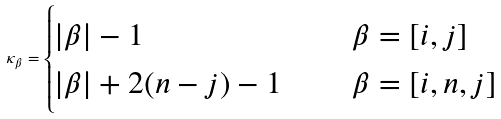Convert formula to latex. <formula><loc_0><loc_0><loc_500><loc_500>\kappa _ { \beta } = \begin{cases} | \beta | - 1 & \quad \ \beta = [ i , j ] \\ | \beta | + 2 ( n - j ) - 1 & \quad \ \beta = [ i , n , j ] \end{cases}</formula> 